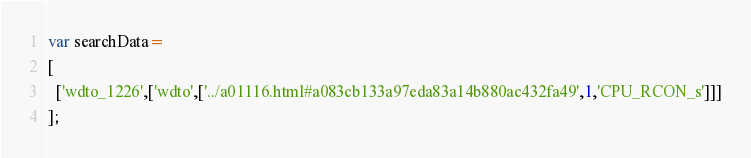<code> <loc_0><loc_0><loc_500><loc_500><_JavaScript_>var searchData=
[
  ['wdto_1226',['wdto',['../a01116.html#a083cb133a97eda83a14b880ac432fa49',1,'CPU_RCON_s']]]
];
</code> 